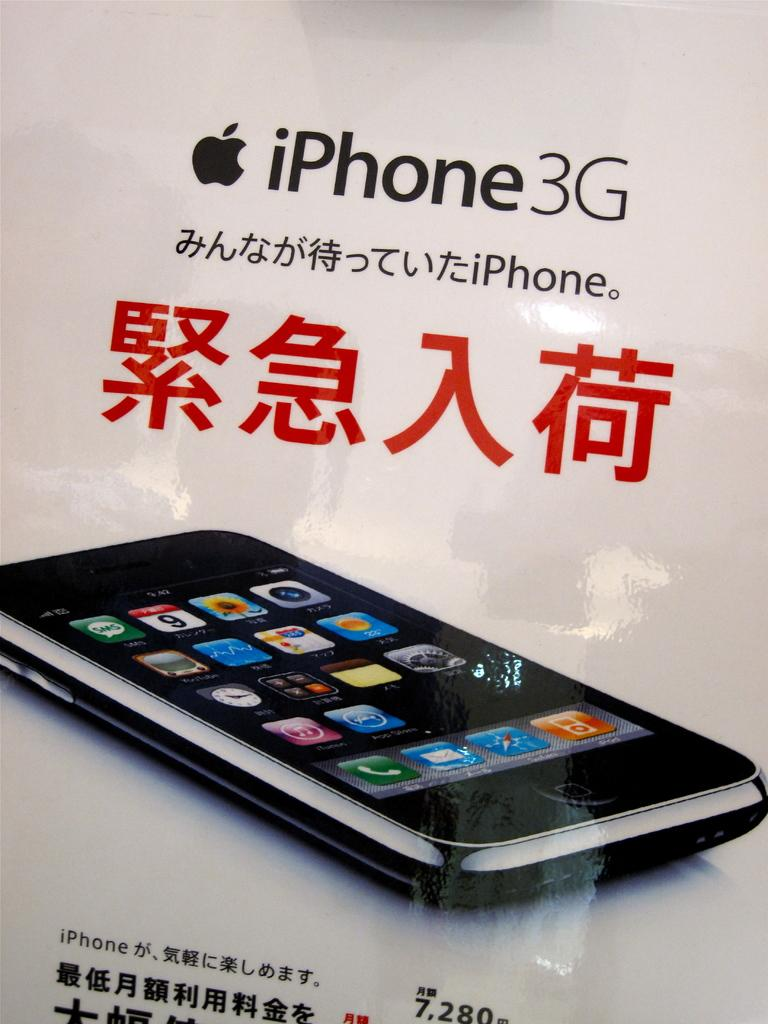<image>
Render a clear and concise summary of the photo. An ad for the iPhone3G with Chinese characters on it. 